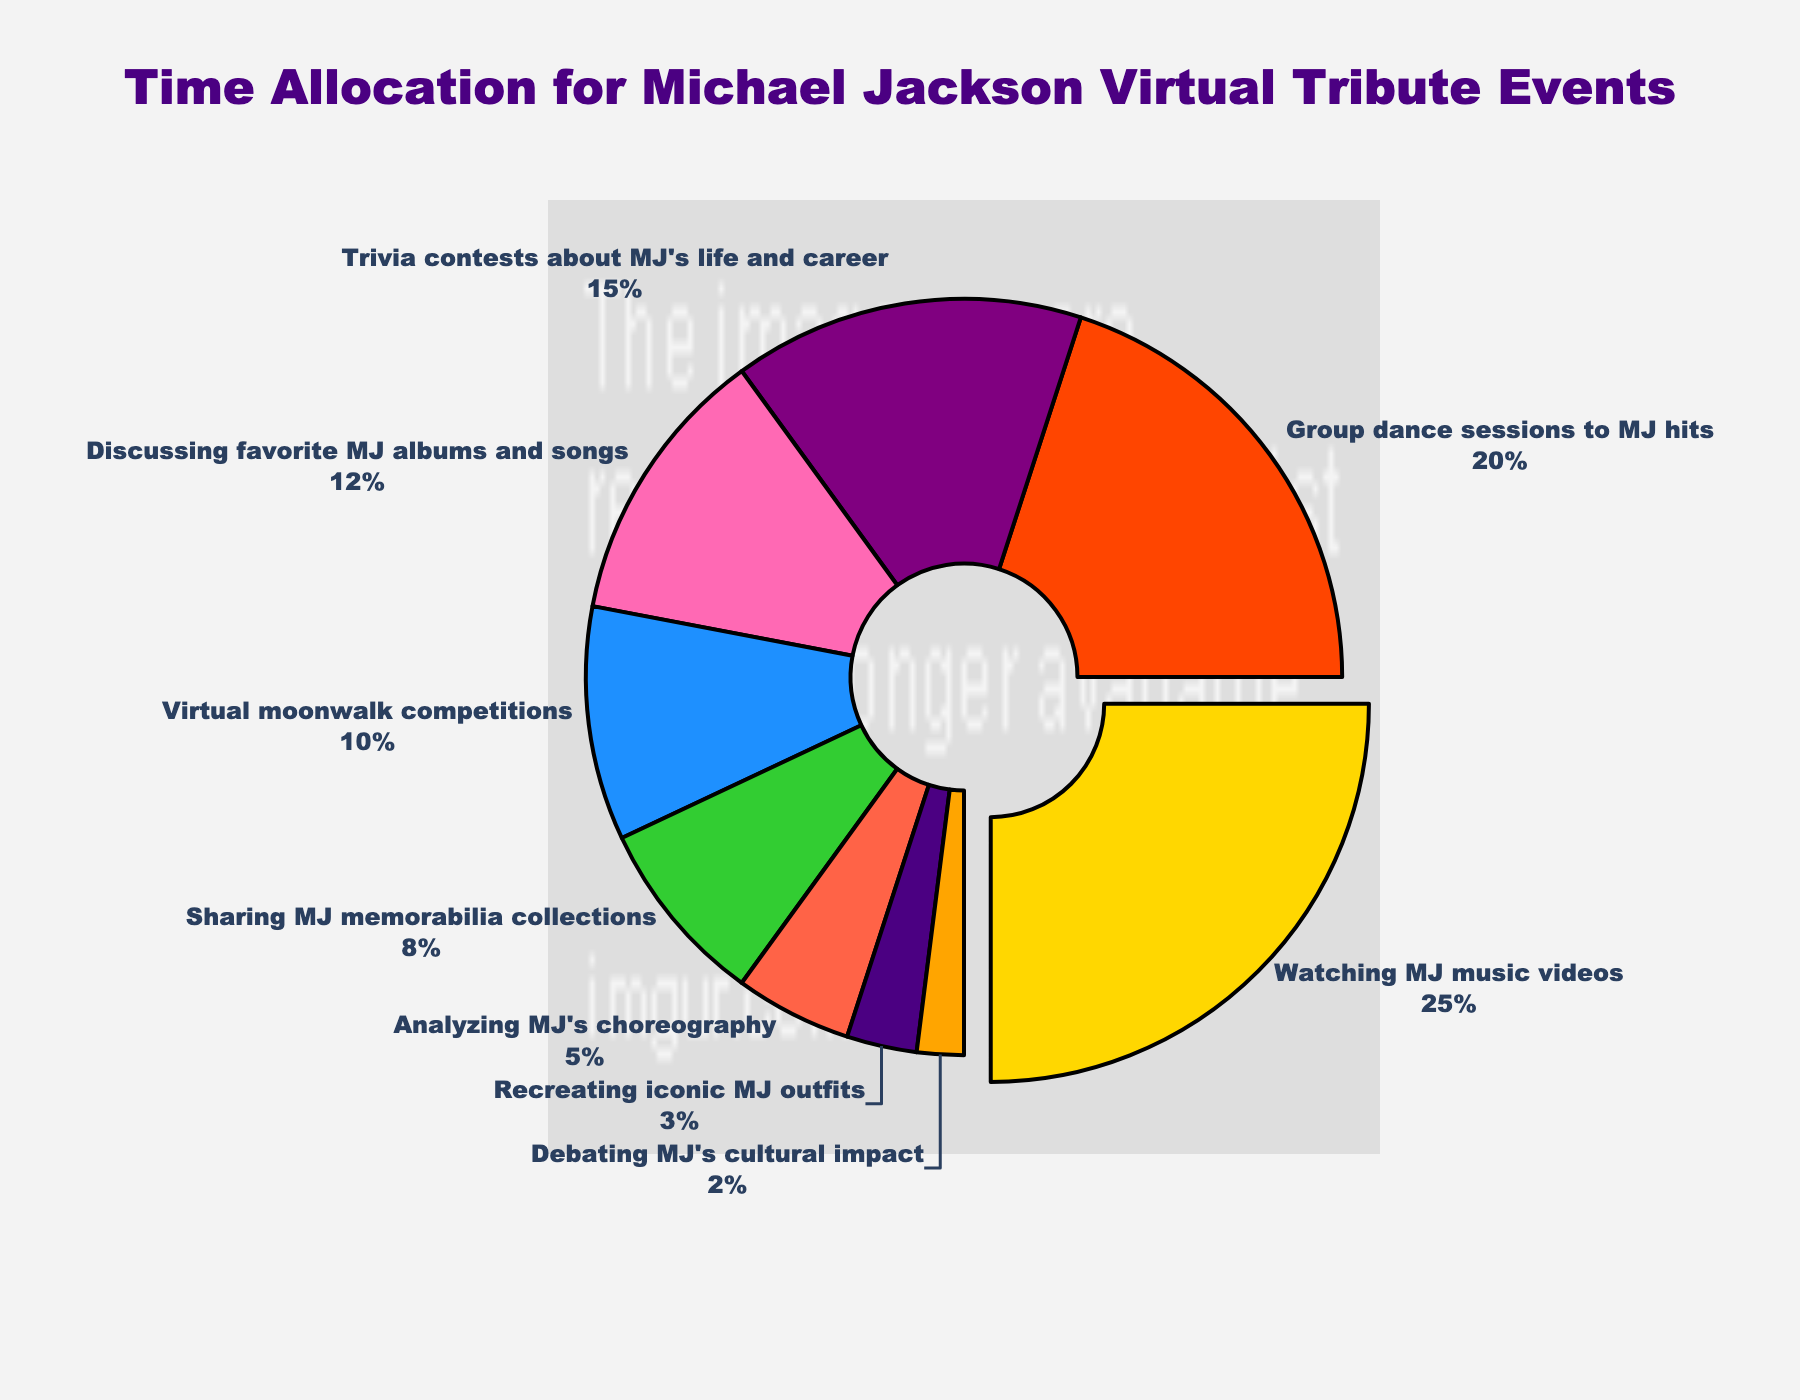Which activity receives the most time allocation? The activity that receives the most time allocation is represented by the largest slice of the pie chart, which is separated slightly from the rest due to the pull parameter. According to the data, "Watching MJ music videos" takes up the largest portion with 25%.
Answer: Watching MJ music videos What percentage of time is collectively spent on activities related to dancing, including group dance sessions and virtual moonwalk competitions? To find the collective time spent on dancing-related activities, add up the percentages for "Group dance sessions to MJ hits" (20%) and "Virtual moonwalk competitions" (10%). 20% + 10% = 30%.
Answer: 30% How does the time allocated to "Analyzing MJ's choreography" compare to "Debating MJ's cultural impact"? Compare the two given percentages: "Analyzing MJ's choreography" receives 5% of the total time, while "Debating MJ's cultural impact" receives 2%. Thus, "Analyzing MJ's choreography" receives more time.
Answer: Analyzing MJ's choreography receives more time Which activities have a smaller time allocation than discussing favorite MJ albums and songs? To determine which activities have less time allocation, compare their percentages with "Discussing favorite MJ albums and songs," which is 12%. The activities with smaller allocations are "Virtual moonwalk competitions" (10%), "Sharing MJ memorabilia collections" (8%), "Analyzing MJ's choreography" (5%), "Recreating iconic MJ outfits" (3%), and "Debating MJ's cultural impact" (2%).
Answer: Virtual moonwalk competitions, Sharing MJ memorabilia collections, Analyzing MJ's choreography, Recreating iconic MJ outfits, Debating MJ's cultural impact If an activity slice is shown in blue, what activity does it represent and what is the percentage allocation? The blue slice corresponds to "Sharing MJ memorabilia collections" according to the custom color palette used in the chart. The time allocation percentage for this activity is 8%.
Answer: Sharing MJ memorabilia collections, 8% Which two activities together make up 27% of the time spent during the events? By inspecting the chart for slices whose percentages add up to 27%, we find that "Discussing favorite MJ albums and songs" (12%) and "Virtual moonwalk competitions" (10%) total 22%, leaving the combination of "Recreating iconic MJ outfits" (3%) and "Debating MJ's cultural impact" (2%) equaling 5%. Together these amount to 27%.
Answer: Discussing favorite MJ albums and songs, Virtual moonwalk competitions, Recreating iconic MJ outfits, Debating MJ's cultural impact How many more times is "Watching MJ music videos" allocated time than "Recreating iconic MJ outfits"? Compare the percentages: "Watching MJ music videos" (25%) and "Recreating iconic MJ outfits" (3%). Divide 25 by 3 to find how many times more. 25 / 3 ≈ 8.33 times.
Answer: 8.33 times 